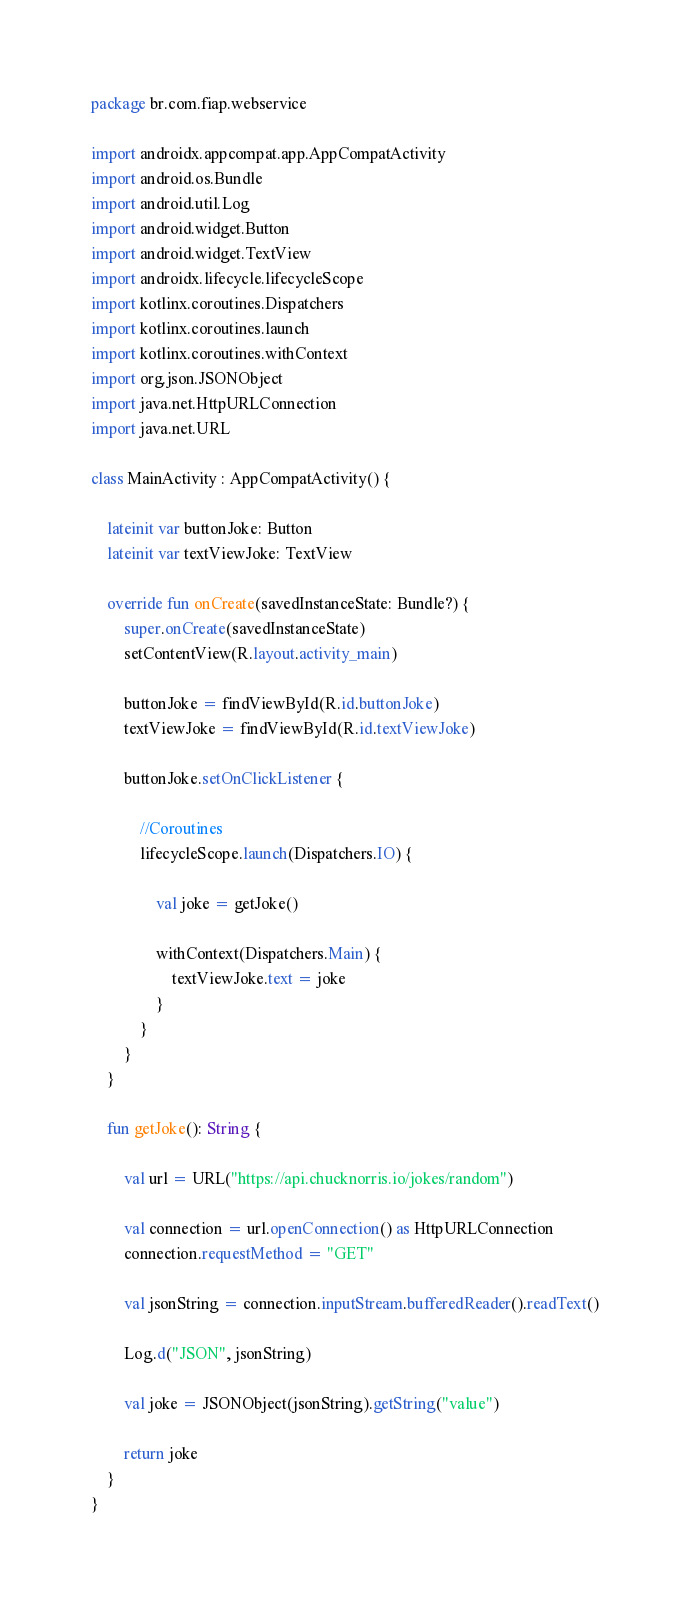Convert code to text. <code><loc_0><loc_0><loc_500><loc_500><_Kotlin_>package br.com.fiap.webservice

import androidx.appcompat.app.AppCompatActivity
import android.os.Bundle
import android.util.Log
import android.widget.Button
import android.widget.TextView
import androidx.lifecycle.lifecycleScope
import kotlinx.coroutines.Dispatchers
import kotlinx.coroutines.launch
import kotlinx.coroutines.withContext
import org.json.JSONObject
import java.net.HttpURLConnection
import java.net.URL

class MainActivity : AppCompatActivity() {

    lateinit var buttonJoke: Button
    lateinit var textViewJoke: TextView

    override fun onCreate(savedInstanceState: Bundle?) {
        super.onCreate(savedInstanceState)
        setContentView(R.layout.activity_main)

        buttonJoke = findViewById(R.id.buttonJoke)
        textViewJoke = findViewById(R.id.textViewJoke)

        buttonJoke.setOnClickListener {

            //Coroutines
            lifecycleScope.launch(Dispatchers.IO) {

                val joke = getJoke()

                withContext(Dispatchers.Main) {
                    textViewJoke.text = joke
                }
            }
        }
    }

    fun getJoke(): String {

        val url = URL("https://api.chucknorris.io/jokes/random")

        val connection = url.openConnection() as HttpURLConnection
        connection.requestMethod = "GET"

        val jsonString = connection.inputStream.bufferedReader().readText()

        Log.d("JSON", jsonString)

        val joke = JSONObject(jsonString).getString("value")

        return joke
    }
}
</code> 